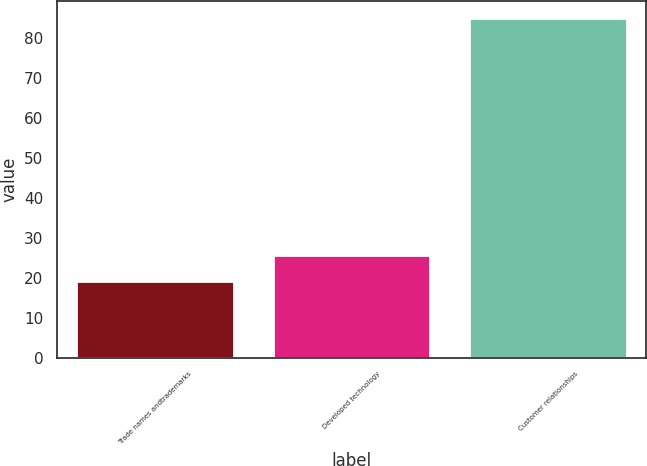Convert chart. <chart><loc_0><loc_0><loc_500><loc_500><bar_chart><fcel>Trade names andtrademarks<fcel>Developed technology<fcel>Customer relationships<nl><fcel>19.1<fcel>25.69<fcel>85<nl></chart> 